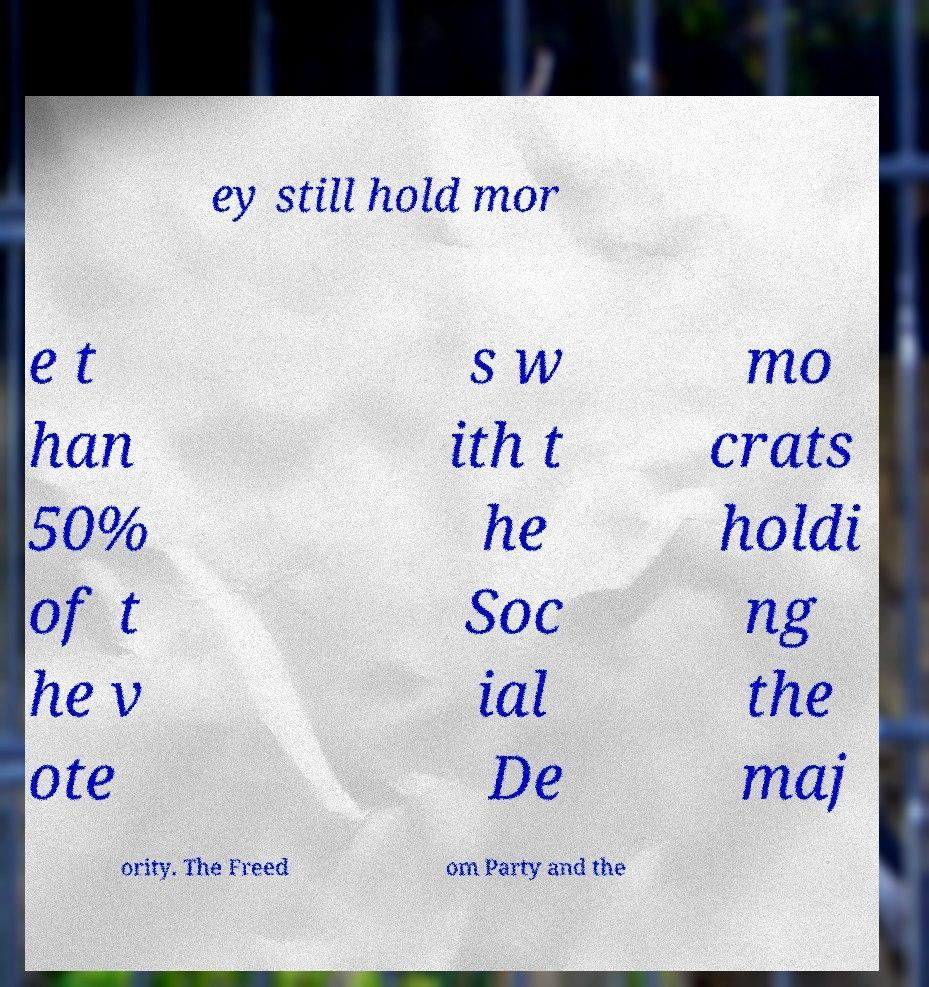There's text embedded in this image that I need extracted. Can you transcribe it verbatim? ey still hold mor e t han 50% of t he v ote s w ith t he Soc ial De mo crats holdi ng the maj ority. The Freed om Party and the 